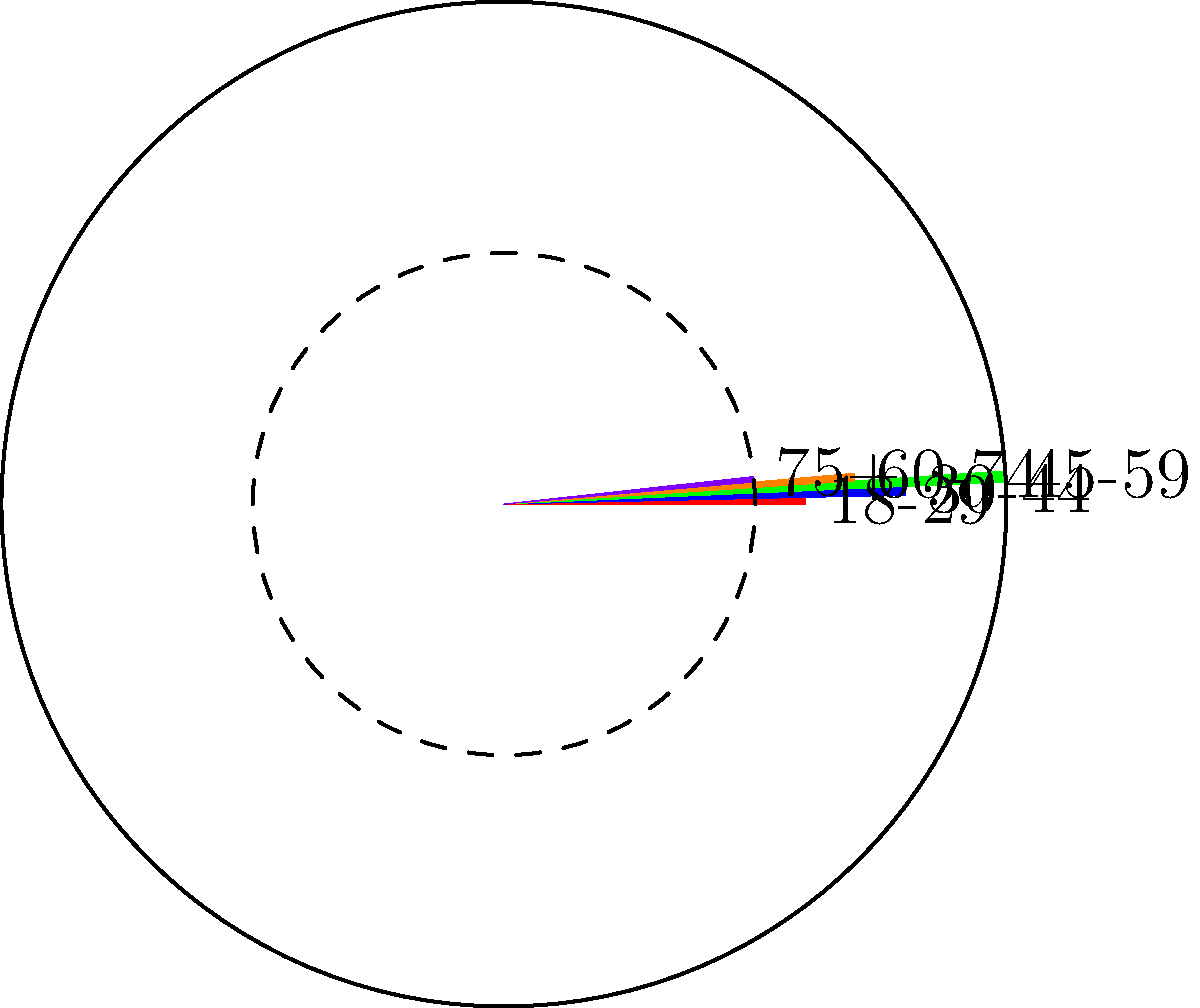Based on the polar area chart showing political party support across different age groups, which age group demonstrates the highest level of support for the party? To determine which age group shows the highest level of support for the party, we need to analyze the polar area chart:

1. The chart is divided into five sectors, each representing an age group.
2. The radial extent of each sector indicates the level of support for that age group.
3. The larger the area of the sector, the higher the support.

Let's examine each age group:

1. 18-29 (red sector): Moderate support
2. 30-44 (blue sector): Large support
3. 45-59 (green sector): Largest support
4. 60-74 (orange sector): Moderate to large support
5. 75+ (purple sector): Smallest support

By comparing the radial extent and area of each sector, we can see that the green sector, representing the 45-59 age group, has the largest area and extends the furthest from the center.

Therefore, the age group that demonstrates the highest level of support for the party is 45-59.
Answer: 45-59 age group 